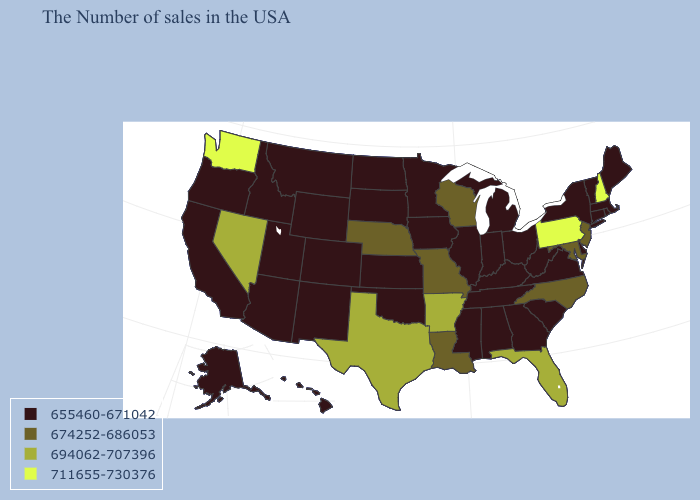How many symbols are there in the legend?
Be succinct. 4. What is the value of California?
Short answer required. 655460-671042. What is the lowest value in the USA?
Concise answer only. 655460-671042. What is the lowest value in states that border Massachusetts?
Keep it brief. 655460-671042. Among the states that border Iowa , does South Dakota have the lowest value?
Answer briefly. Yes. Does the first symbol in the legend represent the smallest category?
Give a very brief answer. Yes. What is the value of Ohio?
Give a very brief answer. 655460-671042. Among the states that border Colorado , does Nebraska have the lowest value?
Be succinct. No. Among the states that border Nebraska , which have the lowest value?
Answer briefly. Iowa, Kansas, South Dakota, Wyoming, Colorado. Name the states that have a value in the range 694062-707396?
Give a very brief answer. Florida, Arkansas, Texas, Nevada. Is the legend a continuous bar?
Answer briefly. No. What is the value of Montana?
Answer briefly. 655460-671042. What is the value of Arizona?
Give a very brief answer. 655460-671042. Name the states that have a value in the range 694062-707396?
Quick response, please. Florida, Arkansas, Texas, Nevada. Does the first symbol in the legend represent the smallest category?
Write a very short answer. Yes. 